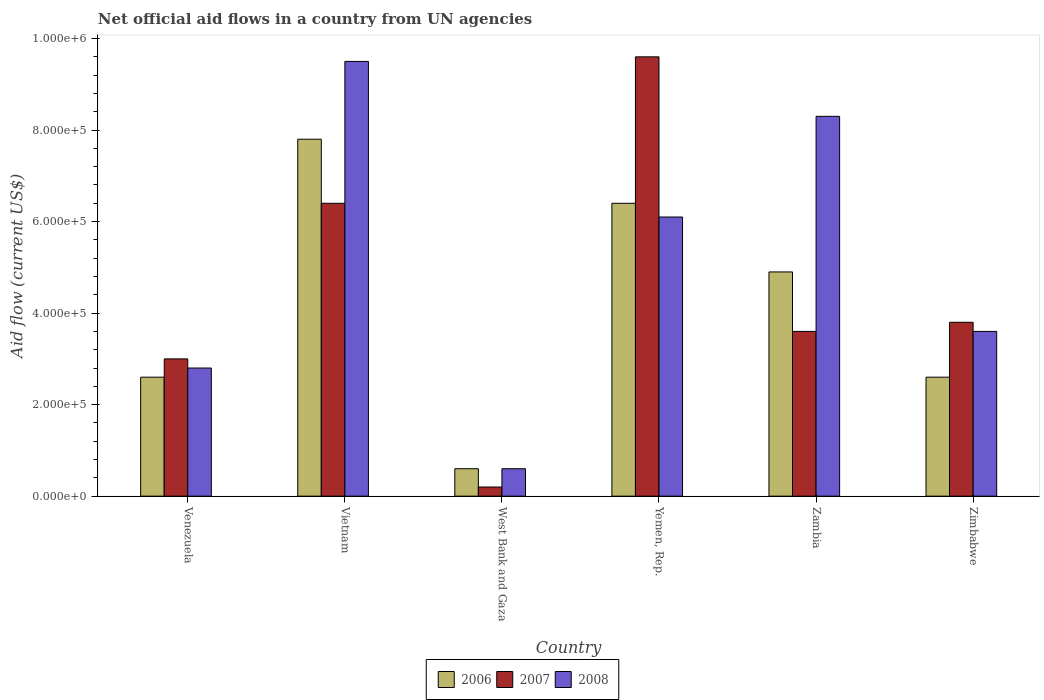How many different coloured bars are there?
Offer a very short reply. 3. Are the number of bars per tick equal to the number of legend labels?
Provide a succinct answer. Yes. Are the number of bars on each tick of the X-axis equal?
Provide a short and direct response. Yes. What is the label of the 3rd group of bars from the left?
Keep it short and to the point. West Bank and Gaza. In how many cases, is the number of bars for a given country not equal to the number of legend labels?
Your response must be concise. 0. What is the net official aid flow in 2007 in Zambia?
Provide a short and direct response. 3.60e+05. Across all countries, what is the maximum net official aid flow in 2007?
Your answer should be very brief. 9.60e+05. Across all countries, what is the minimum net official aid flow in 2006?
Ensure brevity in your answer.  6.00e+04. In which country was the net official aid flow in 2006 maximum?
Offer a terse response. Vietnam. In which country was the net official aid flow in 2006 minimum?
Keep it short and to the point. West Bank and Gaza. What is the total net official aid flow in 2006 in the graph?
Give a very brief answer. 2.49e+06. What is the difference between the net official aid flow in 2008 in Vietnam and that in Zimbabwe?
Give a very brief answer. 5.90e+05. What is the difference between the net official aid flow in 2007 in Zimbabwe and the net official aid flow in 2008 in Vietnam?
Give a very brief answer. -5.70e+05. What is the average net official aid flow in 2006 per country?
Your response must be concise. 4.15e+05. What is the difference between the net official aid flow of/in 2006 and net official aid flow of/in 2008 in West Bank and Gaza?
Provide a succinct answer. 0. What is the ratio of the net official aid flow in 2008 in Venezuela to that in Zimbabwe?
Keep it short and to the point. 0.78. Is the difference between the net official aid flow in 2006 in Yemen, Rep. and Zimbabwe greater than the difference between the net official aid flow in 2008 in Yemen, Rep. and Zimbabwe?
Give a very brief answer. Yes. What is the difference between the highest and the second highest net official aid flow in 2006?
Provide a succinct answer. 1.40e+05. What is the difference between the highest and the lowest net official aid flow in 2006?
Provide a succinct answer. 7.20e+05. In how many countries, is the net official aid flow in 2006 greater than the average net official aid flow in 2006 taken over all countries?
Your answer should be compact. 3. Is the sum of the net official aid flow in 2007 in West Bank and Gaza and Zimbabwe greater than the maximum net official aid flow in 2008 across all countries?
Keep it short and to the point. No. What does the 1st bar from the left in Yemen, Rep. represents?
Offer a very short reply. 2006. Is it the case that in every country, the sum of the net official aid flow in 2006 and net official aid flow in 2008 is greater than the net official aid flow in 2007?
Your response must be concise. Yes. How many countries are there in the graph?
Your answer should be very brief. 6. Are the values on the major ticks of Y-axis written in scientific E-notation?
Keep it short and to the point. Yes. Does the graph contain grids?
Give a very brief answer. No. Where does the legend appear in the graph?
Provide a succinct answer. Bottom center. How many legend labels are there?
Make the answer very short. 3. What is the title of the graph?
Give a very brief answer. Net official aid flows in a country from UN agencies. What is the label or title of the X-axis?
Offer a terse response. Country. What is the label or title of the Y-axis?
Your response must be concise. Aid flow (current US$). What is the Aid flow (current US$) in 2006 in Venezuela?
Offer a terse response. 2.60e+05. What is the Aid flow (current US$) of 2006 in Vietnam?
Make the answer very short. 7.80e+05. What is the Aid flow (current US$) of 2007 in Vietnam?
Ensure brevity in your answer.  6.40e+05. What is the Aid flow (current US$) of 2008 in Vietnam?
Provide a succinct answer. 9.50e+05. What is the Aid flow (current US$) of 2006 in West Bank and Gaza?
Your response must be concise. 6.00e+04. What is the Aid flow (current US$) in 2007 in West Bank and Gaza?
Make the answer very short. 2.00e+04. What is the Aid flow (current US$) of 2008 in West Bank and Gaza?
Your response must be concise. 6.00e+04. What is the Aid flow (current US$) in 2006 in Yemen, Rep.?
Ensure brevity in your answer.  6.40e+05. What is the Aid flow (current US$) of 2007 in Yemen, Rep.?
Offer a very short reply. 9.60e+05. What is the Aid flow (current US$) in 2008 in Yemen, Rep.?
Your answer should be very brief. 6.10e+05. What is the Aid flow (current US$) of 2006 in Zambia?
Ensure brevity in your answer.  4.90e+05. What is the Aid flow (current US$) in 2008 in Zambia?
Ensure brevity in your answer.  8.30e+05. What is the Aid flow (current US$) in 2007 in Zimbabwe?
Provide a short and direct response. 3.80e+05. Across all countries, what is the maximum Aid flow (current US$) in 2006?
Provide a succinct answer. 7.80e+05. Across all countries, what is the maximum Aid flow (current US$) of 2007?
Provide a short and direct response. 9.60e+05. Across all countries, what is the maximum Aid flow (current US$) in 2008?
Provide a succinct answer. 9.50e+05. Across all countries, what is the minimum Aid flow (current US$) in 2008?
Offer a terse response. 6.00e+04. What is the total Aid flow (current US$) in 2006 in the graph?
Keep it short and to the point. 2.49e+06. What is the total Aid flow (current US$) in 2007 in the graph?
Your response must be concise. 2.66e+06. What is the total Aid flow (current US$) of 2008 in the graph?
Your answer should be very brief. 3.09e+06. What is the difference between the Aid flow (current US$) of 2006 in Venezuela and that in Vietnam?
Provide a succinct answer. -5.20e+05. What is the difference between the Aid flow (current US$) of 2007 in Venezuela and that in Vietnam?
Ensure brevity in your answer.  -3.40e+05. What is the difference between the Aid flow (current US$) of 2008 in Venezuela and that in Vietnam?
Your answer should be very brief. -6.70e+05. What is the difference between the Aid flow (current US$) in 2006 in Venezuela and that in West Bank and Gaza?
Your response must be concise. 2.00e+05. What is the difference between the Aid flow (current US$) of 2007 in Venezuela and that in West Bank and Gaza?
Give a very brief answer. 2.80e+05. What is the difference between the Aid flow (current US$) of 2008 in Venezuela and that in West Bank and Gaza?
Your response must be concise. 2.20e+05. What is the difference between the Aid flow (current US$) of 2006 in Venezuela and that in Yemen, Rep.?
Ensure brevity in your answer.  -3.80e+05. What is the difference between the Aid flow (current US$) in 2007 in Venezuela and that in Yemen, Rep.?
Give a very brief answer. -6.60e+05. What is the difference between the Aid flow (current US$) in 2008 in Venezuela and that in Yemen, Rep.?
Give a very brief answer. -3.30e+05. What is the difference between the Aid flow (current US$) in 2006 in Venezuela and that in Zambia?
Provide a short and direct response. -2.30e+05. What is the difference between the Aid flow (current US$) of 2008 in Venezuela and that in Zambia?
Provide a succinct answer. -5.50e+05. What is the difference between the Aid flow (current US$) of 2007 in Venezuela and that in Zimbabwe?
Ensure brevity in your answer.  -8.00e+04. What is the difference between the Aid flow (current US$) in 2006 in Vietnam and that in West Bank and Gaza?
Your answer should be compact. 7.20e+05. What is the difference between the Aid flow (current US$) in 2007 in Vietnam and that in West Bank and Gaza?
Your response must be concise. 6.20e+05. What is the difference between the Aid flow (current US$) in 2008 in Vietnam and that in West Bank and Gaza?
Provide a succinct answer. 8.90e+05. What is the difference between the Aid flow (current US$) in 2006 in Vietnam and that in Yemen, Rep.?
Provide a short and direct response. 1.40e+05. What is the difference between the Aid flow (current US$) in 2007 in Vietnam and that in Yemen, Rep.?
Provide a short and direct response. -3.20e+05. What is the difference between the Aid flow (current US$) in 2006 in Vietnam and that in Zambia?
Your answer should be very brief. 2.90e+05. What is the difference between the Aid flow (current US$) of 2007 in Vietnam and that in Zambia?
Your response must be concise. 2.80e+05. What is the difference between the Aid flow (current US$) of 2006 in Vietnam and that in Zimbabwe?
Ensure brevity in your answer.  5.20e+05. What is the difference between the Aid flow (current US$) of 2008 in Vietnam and that in Zimbabwe?
Your answer should be very brief. 5.90e+05. What is the difference between the Aid flow (current US$) in 2006 in West Bank and Gaza and that in Yemen, Rep.?
Your answer should be compact. -5.80e+05. What is the difference between the Aid flow (current US$) in 2007 in West Bank and Gaza and that in Yemen, Rep.?
Ensure brevity in your answer.  -9.40e+05. What is the difference between the Aid flow (current US$) of 2008 in West Bank and Gaza and that in Yemen, Rep.?
Ensure brevity in your answer.  -5.50e+05. What is the difference between the Aid flow (current US$) of 2006 in West Bank and Gaza and that in Zambia?
Your response must be concise. -4.30e+05. What is the difference between the Aid flow (current US$) of 2008 in West Bank and Gaza and that in Zambia?
Your response must be concise. -7.70e+05. What is the difference between the Aid flow (current US$) of 2006 in West Bank and Gaza and that in Zimbabwe?
Offer a terse response. -2.00e+05. What is the difference between the Aid flow (current US$) of 2007 in West Bank and Gaza and that in Zimbabwe?
Your answer should be very brief. -3.60e+05. What is the difference between the Aid flow (current US$) of 2008 in West Bank and Gaza and that in Zimbabwe?
Provide a short and direct response. -3.00e+05. What is the difference between the Aid flow (current US$) in 2006 in Yemen, Rep. and that in Zambia?
Make the answer very short. 1.50e+05. What is the difference between the Aid flow (current US$) in 2008 in Yemen, Rep. and that in Zambia?
Your answer should be very brief. -2.20e+05. What is the difference between the Aid flow (current US$) of 2006 in Yemen, Rep. and that in Zimbabwe?
Provide a short and direct response. 3.80e+05. What is the difference between the Aid flow (current US$) in 2007 in Yemen, Rep. and that in Zimbabwe?
Your answer should be very brief. 5.80e+05. What is the difference between the Aid flow (current US$) in 2008 in Yemen, Rep. and that in Zimbabwe?
Offer a terse response. 2.50e+05. What is the difference between the Aid flow (current US$) in 2006 in Zambia and that in Zimbabwe?
Ensure brevity in your answer.  2.30e+05. What is the difference between the Aid flow (current US$) of 2007 in Zambia and that in Zimbabwe?
Offer a terse response. -2.00e+04. What is the difference between the Aid flow (current US$) in 2008 in Zambia and that in Zimbabwe?
Your answer should be very brief. 4.70e+05. What is the difference between the Aid flow (current US$) of 2006 in Venezuela and the Aid flow (current US$) of 2007 in Vietnam?
Your answer should be compact. -3.80e+05. What is the difference between the Aid flow (current US$) in 2006 in Venezuela and the Aid flow (current US$) in 2008 in Vietnam?
Offer a terse response. -6.90e+05. What is the difference between the Aid flow (current US$) in 2007 in Venezuela and the Aid flow (current US$) in 2008 in Vietnam?
Give a very brief answer. -6.50e+05. What is the difference between the Aid flow (current US$) of 2006 in Venezuela and the Aid flow (current US$) of 2007 in West Bank and Gaza?
Ensure brevity in your answer.  2.40e+05. What is the difference between the Aid flow (current US$) of 2006 in Venezuela and the Aid flow (current US$) of 2007 in Yemen, Rep.?
Make the answer very short. -7.00e+05. What is the difference between the Aid flow (current US$) of 2006 in Venezuela and the Aid flow (current US$) of 2008 in Yemen, Rep.?
Ensure brevity in your answer.  -3.50e+05. What is the difference between the Aid flow (current US$) of 2007 in Venezuela and the Aid flow (current US$) of 2008 in Yemen, Rep.?
Offer a very short reply. -3.10e+05. What is the difference between the Aid flow (current US$) of 2006 in Venezuela and the Aid flow (current US$) of 2008 in Zambia?
Ensure brevity in your answer.  -5.70e+05. What is the difference between the Aid flow (current US$) in 2007 in Venezuela and the Aid flow (current US$) in 2008 in Zambia?
Your answer should be very brief. -5.30e+05. What is the difference between the Aid flow (current US$) in 2006 in Venezuela and the Aid flow (current US$) in 2008 in Zimbabwe?
Your answer should be compact. -1.00e+05. What is the difference between the Aid flow (current US$) of 2007 in Venezuela and the Aid flow (current US$) of 2008 in Zimbabwe?
Give a very brief answer. -6.00e+04. What is the difference between the Aid flow (current US$) of 2006 in Vietnam and the Aid flow (current US$) of 2007 in West Bank and Gaza?
Your response must be concise. 7.60e+05. What is the difference between the Aid flow (current US$) of 2006 in Vietnam and the Aid flow (current US$) of 2008 in West Bank and Gaza?
Your answer should be compact. 7.20e+05. What is the difference between the Aid flow (current US$) in 2007 in Vietnam and the Aid flow (current US$) in 2008 in West Bank and Gaza?
Your response must be concise. 5.80e+05. What is the difference between the Aid flow (current US$) in 2006 in Vietnam and the Aid flow (current US$) in 2007 in Yemen, Rep.?
Keep it short and to the point. -1.80e+05. What is the difference between the Aid flow (current US$) of 2006 in Vietnam and the Aid flow (current US$) of 2008 in Yemen, Rep.?
Provide a succinct answer. 1.70e+05. What is the difference between the Aid flow (current US$) of 2007 in Vietnam and the Aid flow (current US$) of 2008 in Yemen, Rep.?
Provide a short and direct response. 3.00e+04. What is the difference between the Aid flow (current US$) in 2006 in Vietnam and the Aid flow (current US$) in 2007 in Zambia?
Your answer should be compact. 4.20e+05. What is the difference between the Aid flow (current US$) of 2006 in Vietnam and the Aid flow (current US$) of 2008 in Zambia?
Provide a short and direct response. -5.00e+04. What is the difference between the Aid flow (current US$) in 2007 in Vietnam and the Aid flow (current US$) in 2008 in Zambia?
Ensure brevity in your answer.  -1.90e+05. What is the difference between the Aid flow (current US$) in 2006 in Vietnam and the Aid flow (current US$) in 2007 in Zimbabwe?
Offer a terse response. 4.00e+05. What is the difference between the Aid flow (current US$) in 2006 in Vietnam and the Aid flow (current US$) in 2008 in Zimbabwe?
Make the answer very short. 4.20e+05. What is the difference between the Aid flow (current US$) of 2007 in Vietnam and the Aid flow (current US$) of 2008 in Zimbabwe?
Offer a terse response. 2.80e+05. What is the difference between the Aid flow (current US$) in 2006 in West Bank and Gaza and the Aid flow (current US$) in 2007 in Yemen, Rep.?
Ensure brevity in your answer.  -9.00e+05. What is the difference between the Aid flow (current US$) of 2006 in West Bank and Gaza and the Aid flow (current US$) of 2008 in Yemen, Rep.?
Your answer should be compact. -5.50e+05. What is the difference between the Aid flow (current US$) in 2007 in West Bank and Gaza and the Aid flow (current US$) in 2008 in Yemen, Rep.?
Offer a very short reply. -5.90e+05. What is the difference between the Aid flow (current US$) in 2006 in West Bank and Gaza and the Aid flow (current US$) in 2007 in Zambia?
Provide a succinct answer. -3.00e+05. What is the difference between the Aid flow (current US$) of 2006 in West Bank and Gaza and the Aid flow (current US$) of 2008 in Zambia?
Your answer should be compact. -7.70e+05. What is the difference between the Aid flow (current US$) in 2007 in West Bank and Gaza and the Aid flow (current US$) in 2008 in Zambia?
Keep it short and to the point. -8.10e+05. What is the difference between the Aid flow (current US$) in 2006 in West Bank and Gaza and the Aid flow (current US$) in 2007 in Zimbabwe?
Keep it short and to the point. -3.20e+05. What is the difference between the Aid flow (current US$) of 2007 in West Bank and Gaza and the Aid flow (current US$) of 2008 in Zimbabwe?
Your answer should be compact. -3.40e+05. What is the difference between the Aid flow (current US$) in 2006 in Yemen, Rep. and the Aid flow (current US$) in 2007 in Zambia?
Offer a very short reply. 2.80e+05. What is the difference between the Aid flow (current US$) in 2007 in Yemen, Rep. and the Aid flow (current US$) in 2008 in Zimbabwe?
Your answer should be compact. 6.00e+05. What is the difference between the Aid flow (current US$) of 2006 in Zambia and the Aid flow (current US$) of 2008 in Zimbabwe?
Ensure brevity in your answer.  1.30e+05. What is the difference between the Aid flow (current US$) of 2007 in Zambia and the Aid flow (current US$) of 2008 in Zimbabwe?
Make the answer very short. 0. What is the average Aid flow (current US$) of 2006 per country?
Ensure brevity in your answer.  4.15e+05. What is the average Aid flow (current US$) in 2007 per country?
Provide a succinct answer. 4.43e+05. What is the average Aid flow (current US$) in 2008 per country?
Your answer should be very brief. 5.15e+05. What is the difference between the Aid flow (current US$) in 2006 and Aid flow (current US$) in 2007 in Venezuela?
Make the answer very short. -4.00e+04. What is the difference between the Aid flow (current US$) in 2006 and Aid flow (current US$) in 2008 in Vietnam?
Offer a very short reply. -1.70e+05. What is the difference between the Aid flow (current US$) in 2007 and Aid flow (current US$) in 2008 in Vietnam?
Give a very brief answer. -3.10e+05. What is the difference between the Aid flow (current US$) in 2006 and Aid flow (current US$) in 2007 in West Bank and Gaza?
Keep it short and to the point. 4.00e+04. What is the difference between the Aid flow (current US$) of 2007 and Aid flow (current US$) of 2008 in West Bank and Gaza?
Give a very brief answer. -4.00e+04. What is the difference between the Aid flow (current US$) in 2006 and Aid flow (current US$) in 2007 in Yemen, Rep.?
Offer a terse response. -3.20e+05. What is the difference between the Aid flow (current US$) of 2006 and Aid flow (current US$) of 2008 in Yemen, Rep.?
Your answer should be very brief. 3.00e+04. What is the difference between the Aid flow (current US$) of 2006 and Aid flow (current US$) of 2008 in Zambia?
Give a very brief answer. -3.40e+05. What is the difference between the Aid flow (current US$) in 2007 and Aid flow (current US$) in 2008 in Zambia?
Offer a very short reply. -4.70e+05. What is the difference between the Aid flow (current US$) in 2006 and Aid flow (current US$) in 2008 in Zimbabwe?
Keep it short and to the point. -1.00e+05. What is the ratio of the Aid flow (current US$) of 2007 in Venezuela to that in Vietnam?
Give a very brief answer. 0.47. What is the ratio of the Aid flow (current US$) of 2008 in Venezuela to that in Vietnam?
Make the answer very short. 0.29. What is the ratio of the Aid flow (current US$) in 2006 in Venezuela to that in West Bank and Gaza?
Offer a very short reply. 4.33. What is the ratio of the Aid flow (current US$) of 2007 in Venezuela to that in West Bank and Gaza?
Your answer should be very brief. 15. What is the ratio of the Aid flow (current US$) of 2008 in Venezuela to that in West Bank and Gaza?
Offer a very short reply. 4.67. What is the ratio of the Aid flow (current US$) of 2006 in Venezuela to that in Yemen, Rep.?
Provide a short and direct response. 0.41. What is the ratio of the Aid flow (current US$) in 2007 in Venezuela to that in Yemen, Rep.?
Provide a short and direct response. 0.31. What is the ratio of the Aid flow (current US$) of 2008 in Venezuela to that in Yemen, Rep.?
Ensure brevity in your answer.  0.46. What is the ratio of the Aid flow (current US$) in 2006 in Venezuela to that in Zambia?
Your answer should be compact. 0.53. What is the ratio of the Aid flow (current US$) in 2007 in Venezuela to that in Zambia?
Your answer should be compact. 0.83. What is the ratio of the Aid flow (current US$) of 2008 in Venezuela to that in Zambia?
Give a very brief answer. 0.34. What is the ratio of the Aid flow (current US$) in 2006 in Venezuela to that in Zimbabwe?
Offer a very short reply. 1. What is the ratio of the Aid flow (current US$) in 2007 in Venezuela to that in Zimbabwe?
Give a very brief answer. 0.79. What is the ratio of the Aid flow (current US$) in 2007 in Vietnam to that in West Bank and Gaza?
Your answer should be very brief. 32. What is the ratio of the Aid flow (current US$) of 2008 in Vietnam to that in West Bank and Gaza?
Your answer should be compact. 15.83. What is the ratio of the Aid flow (current US$) of 2006 in Vietnam to that in Yemen, Rep.?
Offer a very short reply. 1.22. What is the ratio of the Aid flow (current US$) in 2007 in Vietnam to that in Yemen, Rep.?
Your response must be concise. 0.67. What is the ratio of the Aid flow (current US$) of 2008 in Vietnam to that in Yemen, Rep.?
Your answer should be very brief. 1.56. What is the ratio of the Aid flow (current US$) in 2006 in Vietnam to that in Zambia?
Offer a terse response. 1.59. What is the ratio of the Aid flow (current US$) in 2007 in Vietnam to that in Zambia?
Provide a succinct answer. 1.78. What is the ratio of the Aid flow (current US$) of 2008 in Vietnam to that in Zambia?
Your response must be concise. 1.14. What is the ratio of the Aid flow (current US$) in 2006 in Vietnam to that in Zimbabwe?
Provide a succinct answer. 3. What is the ratio of the Aid flow (current US$) in 2007 in Vietnam to that in Zimbabwe?
Keep it short and to the point. 1.68. What is the ratio of the Aid flow (current US$) of 2008 in Vietnam to that in Zimbabwe?
Offer a terse response. 2.64. What is the ratio of the Aid flow (current US$) in 2006 in West Bank and Gaza to that in Yemen, Rep.?
Your answer should be compact. 0.09. What is the ratio of the Aid flow (current US$) in 2007 in West Bank and Gaza to that in Yemen, Rep.?
Ensure brevity in your answer.  0.02. What is the ratio of the Aid flow (current US$) of 2008 in West Bank and Gaza to that in Yemen, Rep.?
Your answer should be very brief. 0.1. What is the ratio of the Aid flow (current US$) in 2006 in West Bank and Gaza to that in Zambia?
Keep it short and to the point. 0.12. What is the ratio of the Aid flow (current US$) of 2007 in West Bank and Gaza to that in Zambia?
Offer a terse response. 0.06. What is the ratio of the Aid flow (current US$) of 2008 in West Bank and Gaza to that in Zambia?
Provide a short and direct response. 0.07. What is the ratio of the Aid flow (current US$) in 2006 in West Bank and Gaza to that in Zimbabwe?
Provide a succinct answer. 0.23. What is the ratio of the Aid flow (current US$) in 2007 in West Bank and Gaza to that in Zimbabwe?
Give a very brief answer. 0.05. What is the ratio of the Aid flow (current US$) of 2008 in West Bank and Gaza to that in Zimbabwe?
Your answer should be compact. 0.17. What is the ratio of the Aid flow (current US$) in 2006 in Yemen, Rep. to that in Zambia?
Your answer should be very brief. 1.31. What is the ratio of the Aid flow (current US$) in 2007 in Yemen, Rep. to that in Zambia?
Ensure brevity in your answer.  2.67. What is the ratio of the Aid flow (current US$) of 2008 in Yemen, Rep. to that in Zambia?
Offer a terse response. 0.73. What is the ratio of the Aid flow (current US$) in 2006 in Yemen, Rep. to that in Zimbabwe?
Keep it short and to the point. 2.46. What is the ratio of the Aid flow (current US$) in 2007 in Yemen, Rep. to that in Zimbabwe?
Your response must be concise. 2.53. What is the ratio of the Aid flow (current US$) in 2008 in Yemen, Rep. to that in Zimbabwe?
Offer a very short reply. 1.69. What is the ratio of the Aid flow (current US$) in 2006 in Zambia to that in Zimbabwe?
Your response must be concise. 1.88. What is the ratio of the Aid flow (current US$) in 2008 in Zambia to that in Zimbabwe?
Provide a succinct answer. 2.31. What is the difference between the highest and the second highest Aid flow (current US$) in 2008?
Keep it short and to the point. 1.20e+05. What is the difference between the highest and the lowest Aid flow (current US$) of 2006?
Your answer should be compact. 7.20e+05. What is the difference between the highest and the lowest Aid flow (current US$) of 2007?
Provide a short and direct response. 9.40e+05. What is the difference between the highest and the lowest Aid flow (current US$) of 2008?
Keep it short and to the point. 8.90e+05. 